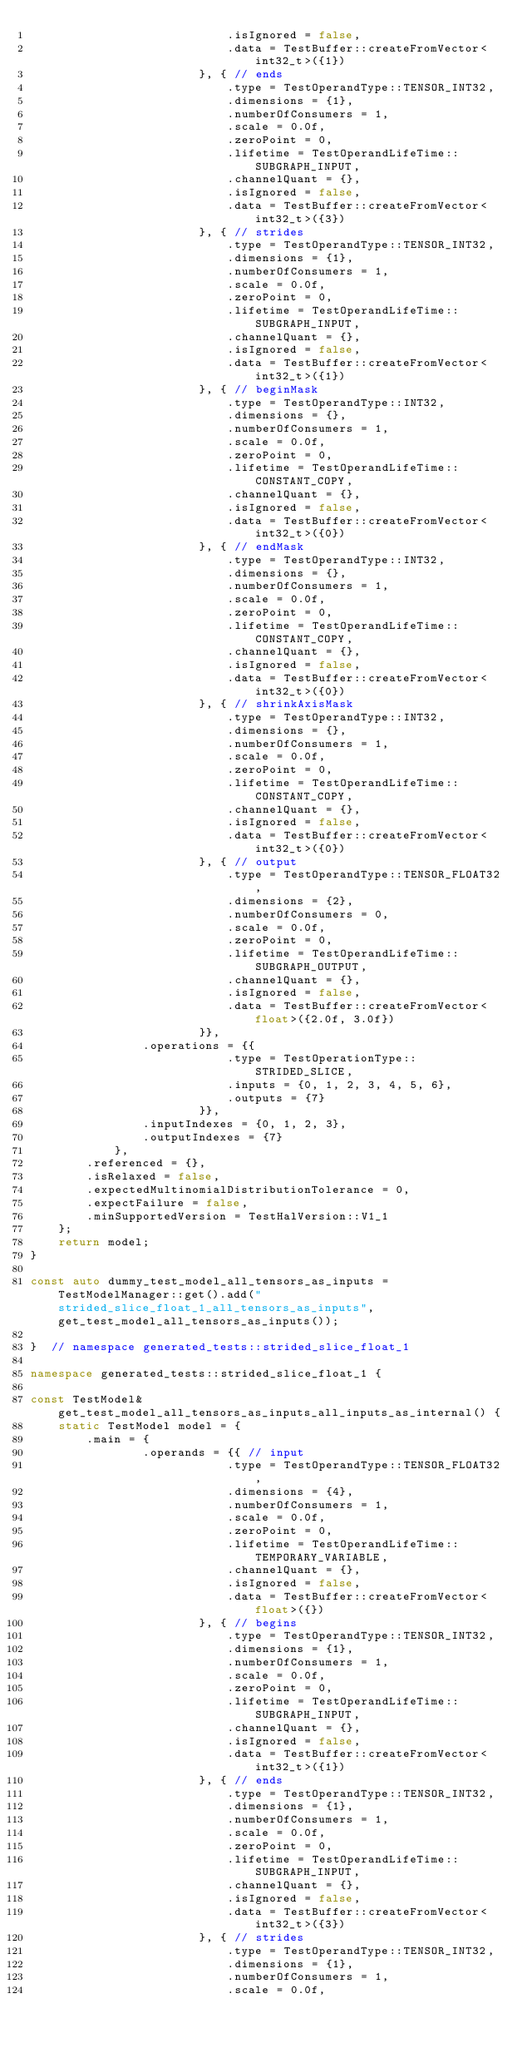<code> <loc_0><loc_0><loc_500><loc_500><_C++_>                            .isIgnored = false,
                            .data = TestBuffer::createFromVector<int32_t>({1})
                        }, { // ends
                            .type = TestOperandType::TENSOR_INT32,
                            .dimensions = {1},
                            .numberOfConsumers = 1,
                            .scale = 0.0f,
                            .zeroPoint = 0,
                            .lifetime = TestOperandLifeTime::SUBGRAPH_INPUT,
                            .channelQuant = {},
                            .isIgnored = false,
                            .data = TestBuffer::createFromVector<int32_t>({3})
                        }, { // strides
                            .type = TestOperandType::TENSOR_INT32,
                            .dimensions = {1},
                            .numberOfConsumers = 1,
                            .scale = 0.0f,
                            .zeroPoint = 0,
                            .lifetime = TestOperandLifeTime::SUBGRAPH_INPUT,
                            .channelQuant = {},
                            .isIgnored = false,
                            .data = TestBuffer::createFromVector<int32_t>({1})
                        }, { // beginMask
                            .type = TestOperandType::INT32,
                            .dimensions = {},
                            .numberOfConsumers = 1,
                            .scale = 0.0f,
                            .zeroPoint = 0,
                            .lifetime = TestOperandLifeTime::CONSTANT_COPY,
                            .channelQuant = {},
                            .isIgnored = false,
                            .data = TestBuffer::createFromVector<int32_t>({0})
                        }, { // endMask
                            .type = TestOperandType::INT32,
                            .dimensions = {},
                            .numberOfConsumers = 1,
                            .scale = 0.0f,
                            .zeroPoint = 0,
                            .lifetime = TestOperandLifeTime::CONSTANT_COPY,
                            .channelQuant = {},
                            .isIgnored = false,
                            .data = TestBuffer::createFromVector<int32_t>({0})
                        }, { // shrinkAxisMask
                            .type = TestOperandType::INT32,
                            .dimensions = {},
                            .numberOfConsumers = 1,
                            .scale = 0.0f,
                            .zeroPoint = 0,
                            .lifetime = TestOperandLifeTime::CONSTANT_COPY,
                            .channelQuant = {},
                            .isIgnored = false,
                            .data = TestBuffer::createFromVector<int32_t>({0})
                        }, { // output
                            .type = TestOperandType::TENSOR_FLOAT32,
                            .dimensions = {2},
                            .numberOfConsumers = 0,
                            .scale = 0.0f,
                            .zeroPoint = 0,
                            .lifetime = TestOperandLifeTime::SUBGRAPH_OUTPUT,
                            .channelQuant = {},
                            .isIgnored = false,
                            .data = TestBuffer::createFromVector<float>({2.0f, 3.0f})
                        }},
                .operations = {{
                            .type = TestOperationType::STRIDED_SLICE,
                            .inputs = {0, 1, 2, 3, 4, 5, 6},
                            .outputs = {7}
                        }},
                .inputIndexes = {0, 1, 2, 3},
                .outputIndexes = {7}
            },
        .referenced = {},
        .isRelaxed = false,
        .expectedMultinomialDistributionTolerance = 0,
        .expectFailure = false,
        .minSupportedVersion = TestHalVersion::V1_1
    };
    return model;
}

const auto dummy_test_model_all_tensors_as_inputs = TestModelManager::get().add("strided_slice_float_1_all_tensors_as_inputs", get_test_model_all_tensors_as_inputs());

}  // namespace generated_tests::strided_slice_float_1

namespace generated_tests::strided_slice_float_1 {

const TestModel& get_test_model_all_tensors_as_inputs_all_inputs_as_internal() {
    static TestModel model = {
        .main = {
                .operands = {{ // input
                            .type = TestOperandType::TENSOR_FLOAT32,
                            .dimensions = {4},
                            .numberOfConsumers = 1,
                            .scale = 0.0f,
                            .zeroPoint = 0,
                            .lifetime = TestOperandLifeTime::TEMPORARY_VARIABLE,
                            .channelQuant = {},
                            .isIgnored = false,
                            .data = TestBuffer::createFromVector<float>({})
                        }, { // begins
                            .type = TestOperandType::TENSOR_INT32,
                            .dimensions = {1},
                            .numberOfConsumers = 1,
                            .scale = 0.0f,
                            .zeroPoint = 0,
                            .lifetime = TestOperandLifeTime::SUBGRAPH_INPUT,
                            .channelQuant = {},
                            .isIgnored = false,
                            .data = TestBuffer::createFromVector<int32_t>({1})
                        }, { // ends
                            .type = TestOperandType::TENSOR_INT32,
                            .dimensions = {1},
                            .numberOfConsumers = 1,
                            .scale = 0.0f,
                            .zeroPoint = 0,
                            .lifetime = TestOperandLifeTime::SUBGRAPH_INPUT,
                            .channelQuant = {},
                            .isIgnored = false,
                            .data = TestBuffer::createFromVector<int32_t>({3})
                        }, { // strides
                            .type = TestOperandType::TENSOR_INT32,
                            .dimensions = {1},
                            .numberOfConsumers = 1,
                            .scale = 0.0f,</code> 